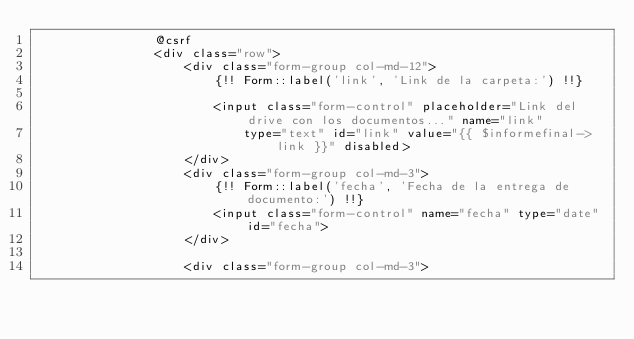Convert code to text. <code><loc_0><loc_0><loc_500><loc_500><_PHP_>                @csrf
                <div class="row">
                    <div class="form-group col-md-12">
                        {!! Form::label('link', 'Link de la carpeta:') !!}

                        <input class="form-control" placeholder="Link del drive con los documentos..." name="link"
                            type="text" id="link" value="{{ $informefinal->link }}" disabled>
                    </div>
                    <div class="form-group col-md-3">
                        {!! Form::label('fecha', 'Fecha de la entrega de documento:') !!}
                        <input class="form-control" name="fecha" type="date" id="fecha">
                    </div>

                    <div class="form-group col-md-3"></code> 